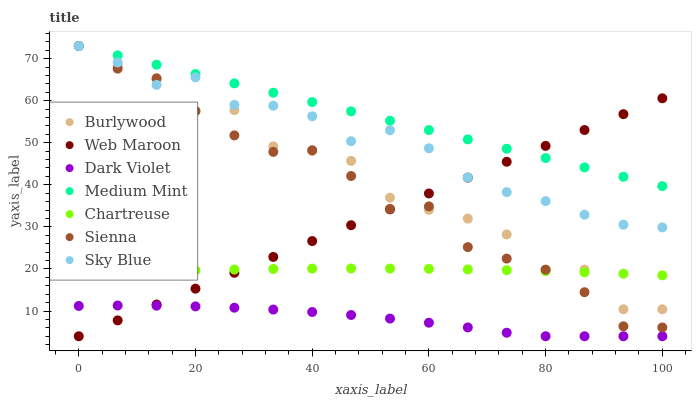Does Dark Violet have the minimum area under the curve?
Answer yes or no. Yes. Does Medium Mint have the maximum area under the curve?
Answer yes or no. Yes. Does Burlywood have the minimum area under the curve?
Answer yes or no. No. Does Burlywood have the maximum area under the curve?
Answer yes or no. No. Is Web Maroon the smoothest?
Answer yes or no. Yes. Is Burlywood the roughest?
Answer yes or no. Yes. Is Burlywood the smoothest?
Answer yes or no. No. Is Web Maroon the roughest?
Answer yes or no. No. Does Web Maroon have the lowest value?
Answer yes or no. Yes. Does Burlywood have the lowest value?
Answer yes or no. No. Does Sky Blue have the highest value?
Answer yes or no. Yes. Does Web Maroon have the highest value?
Answer yes or no. No. Is Dark Violet less than Chartreuse?
Answer yes or no. Yes. Is Medium Mint greater than Chartreuse?
Answer yes or no. Yes. Does Sky Blue intersect Web Maroon?
Answer yes or no. Yes. Is Sky Blue less than Web Maroon?
Answer yes or no. No. Is Sky Blue greater than Web Maroon?
Answer yes or no. No. Does Dark Violet intersect Chartreuse?
Answer yes or no. No. 